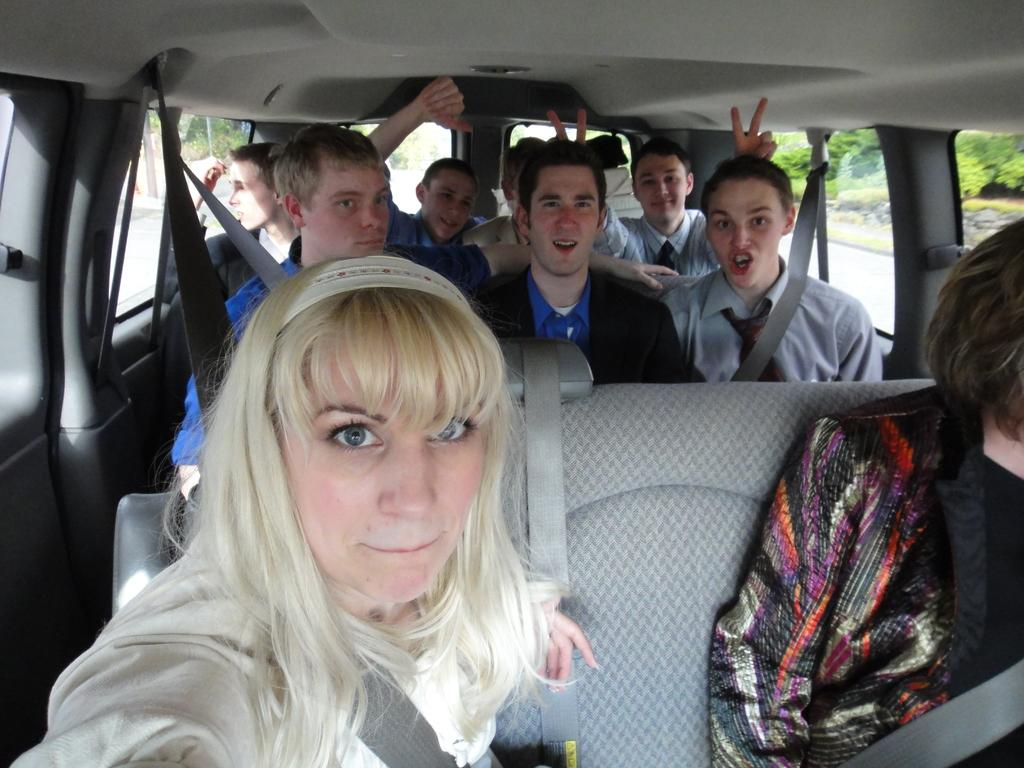What is present in the image? There are people in the image. What are the people doing in the image? The people are sitting in a car. What type of head is visible on the people in the image? There is no specific type of head mentioned or visible in the image; the people have regular human heads. Can you tell me how many times the people in the image jump in the air? There is no indication in the image that the people are jumping or performing any such action. 